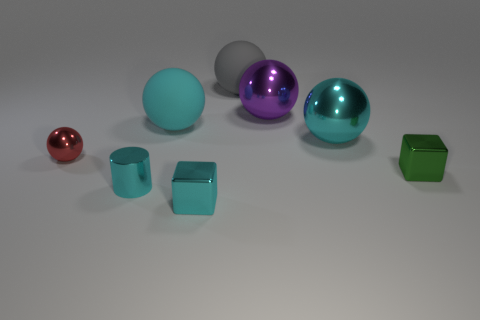There is a tiny thing that is the same color as the tiny metal cylinder; what is its material?
Offer a terse response. Metal. Are there fewer large matte things to the left of the red ball than gray matte spheres that are on the right side of the tiny green thing?
Offer a very short reply. No. How many spheres are large green objects or big things?
Your answer should be very brief. 4. Does the big cyan ball on the right side of the big gray matte sphere have the same material as the small block to the right of the purple shiny sphere?
Your answer should be very brief. Yes. What is the shape of the cyan thing that is the same size as the cyan metallic cube?
Ensure brevity in your answer.  Cylinder. What number of other things are there of the same color as the small shiny ball?
Provide a succinct answer. 0. What number of yellow things are big spheres or small shiny things?
Offer a very short reply. 0. Does the cyan thing that is in front of the cyan metal cylinder have the same shape as the large cyan object behind the big cyan shiny thing?
Make the answer very short. No. How many other objects are the same material as the big purple object?
Your response must be concise. 5. There is a metallic ball in front of the big metal thing that is to the right of the large purple thing; are there any purple metal objects that are to the left of it?
Provide a succinct answer. No. 